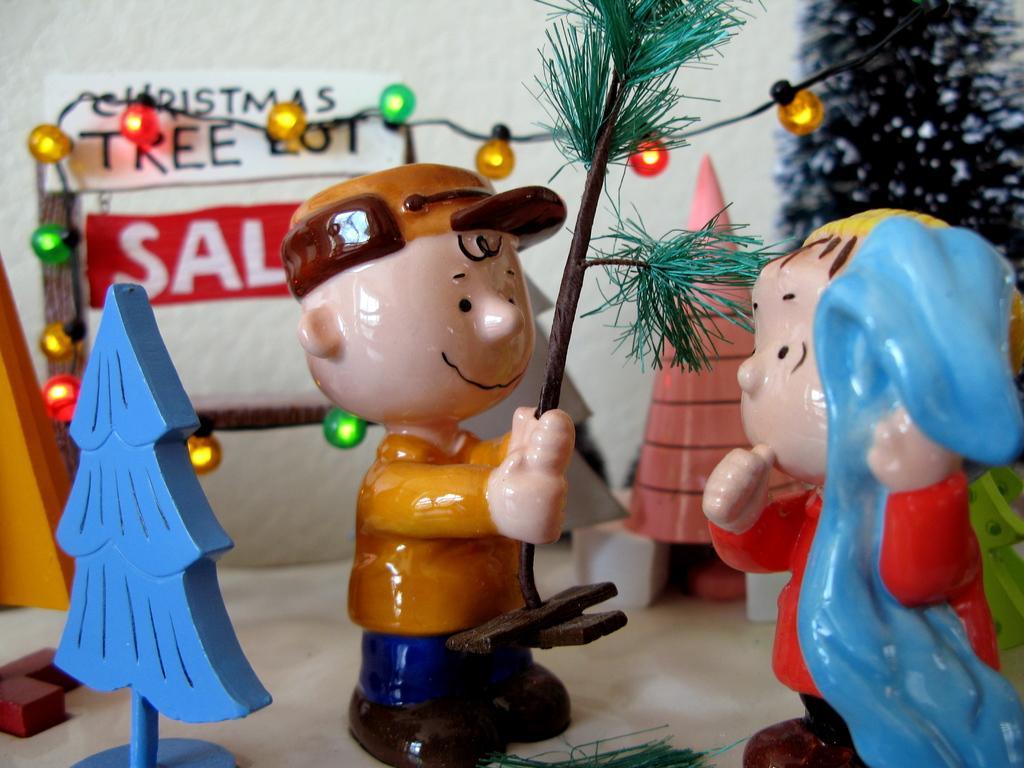In one or two sentences, can you explain what this image depicts? In the foreground of the picture there are toys, light and other objects. In the background we can see wall. 